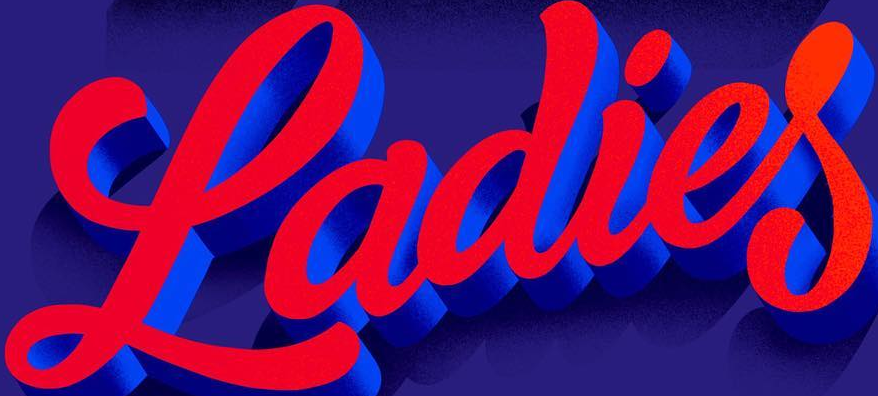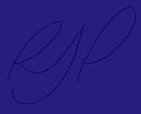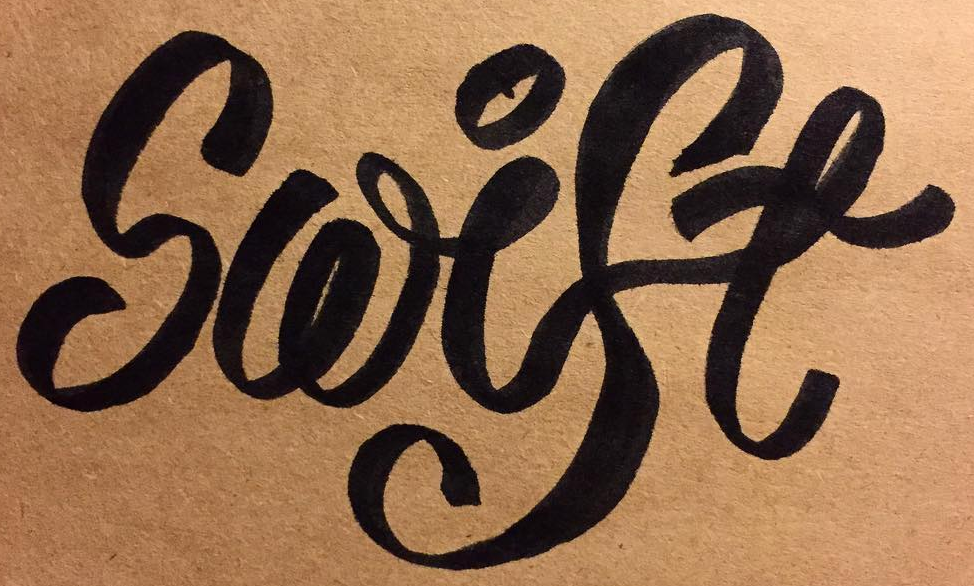What text appears in these images from left to right, separated by a semicolon? Ladies; RJP; Swise 